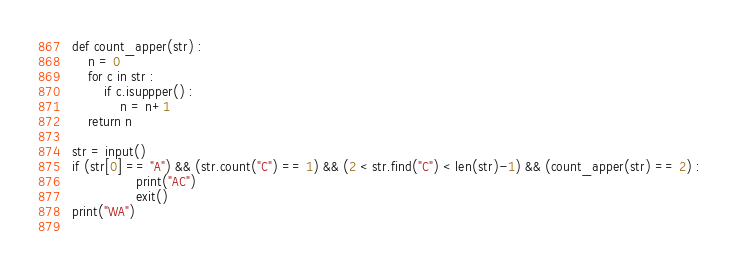Convert code to text. <code><loc_0><loc_0><loc_500><loc_500><_Python_>def count_apper(str) :
    n = 0
    for c in str :
        if c.isuppper() :
            n = n+1
    return n

str = input()
if (str[0] == "A") && (str.count("C") == 1) && (2 < str.find("C") < len(str)-1) && (count_apper(str) == 2) :
                print("AC")
                exit()
print("WA")
    </code> 